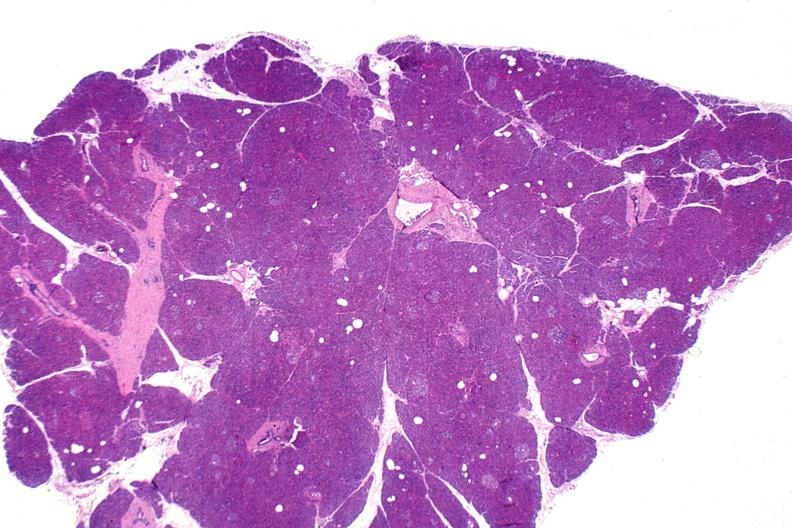where is this?
Answer the question using a single word or phrase. Pancreas 